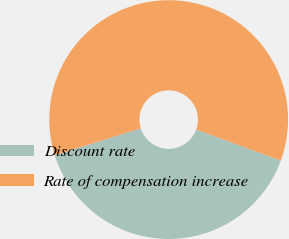Convert chart to OTSL. <chart><loc_0><loc_0><loc_500><loc_500><pie_chart><fcel>Discount rate<fcel>Rate of compensation increase<nl><fcel>39.6%<fcel>60.4%<nl></chart> 